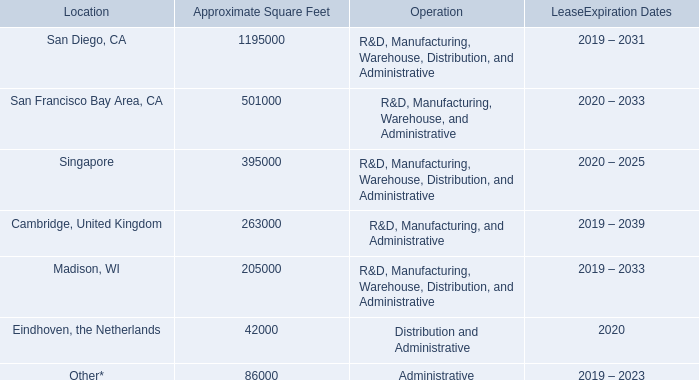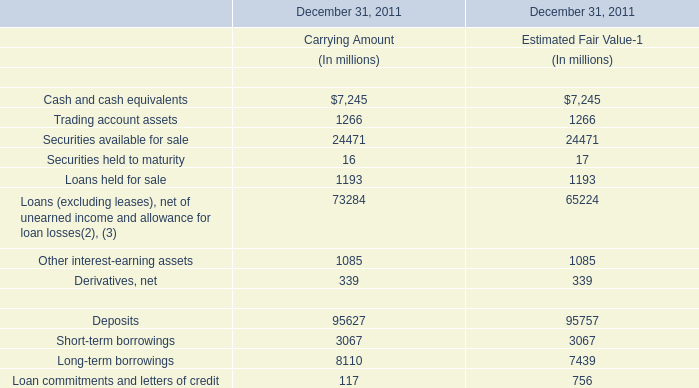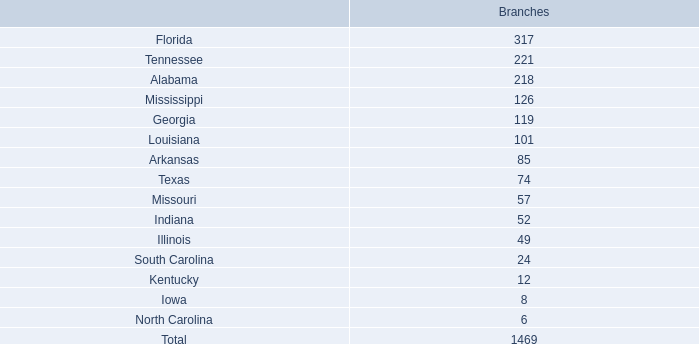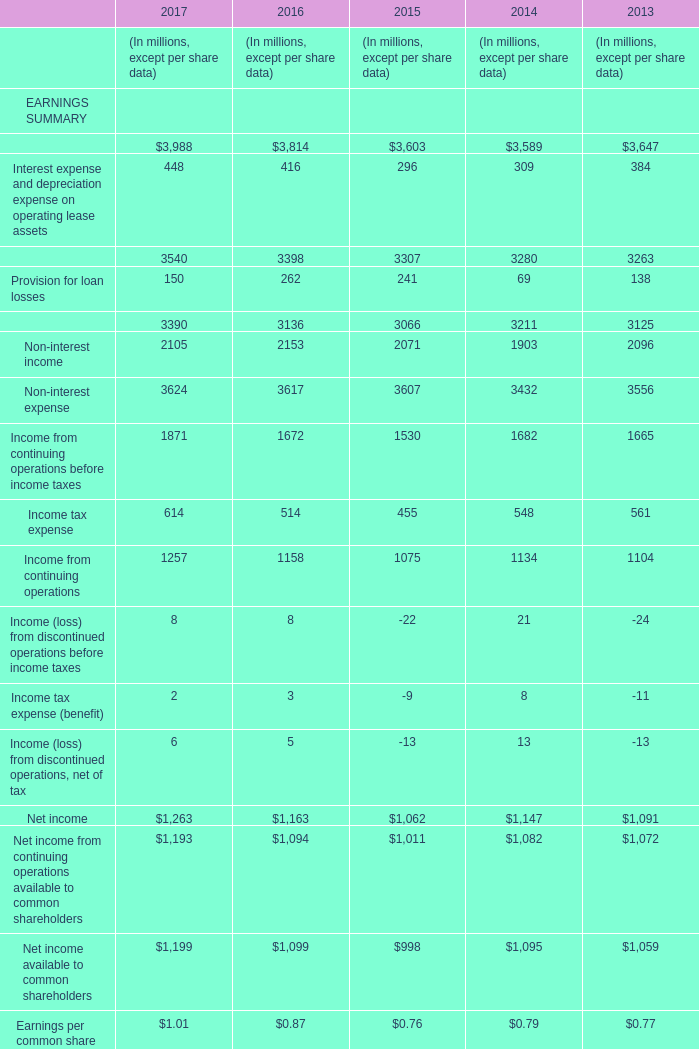What is the ratio of Interest income, including other financing income in2017 to the Cash and cash equivalents for Carrying Amount ? (in million) 
Computations: (3988 / 7245)
Answer: 0.55045. 